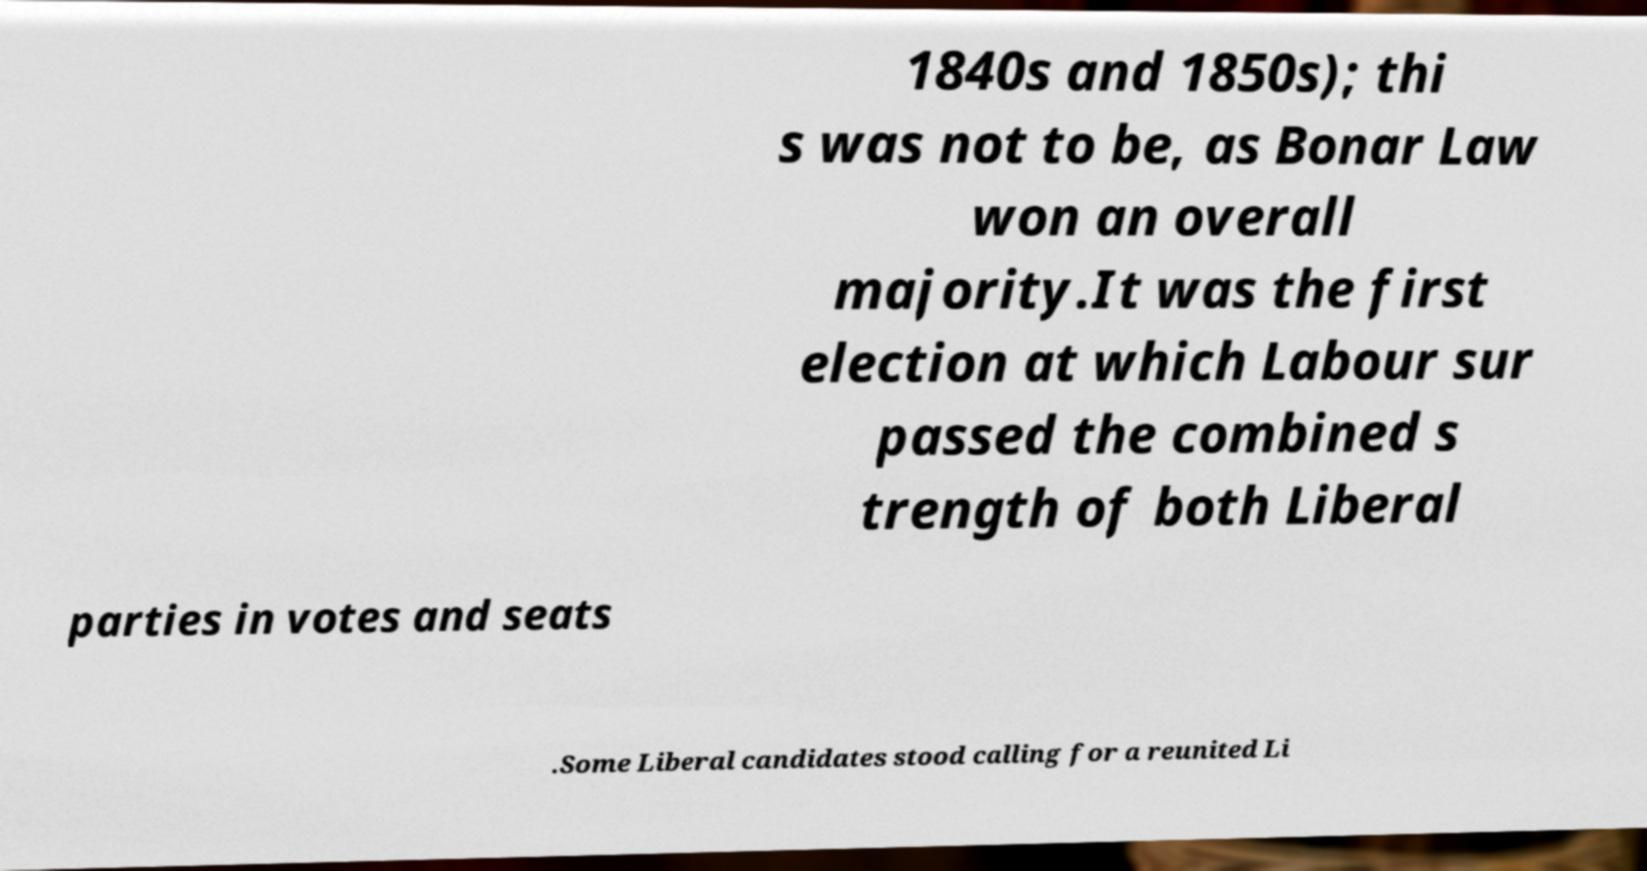I need the written content from this picture converted into text. Can you do that? 1840s and 1850s); thi s was not to be, as Bonar Law won an overall majority.It was the first election at which Labour sur passed the combined s trength of both Liberal parties in votes and seats .Some Liberal candidates stood calling for a reunited Li 